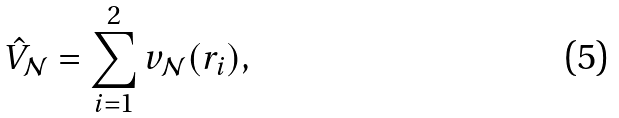<formula> <loc_0><loc_0><loc_500><loc_500>\hat { V } _ { \mathcal { N } } = \sum ^ { 2 } _ { i = 1 } v _ { \mathcal { N } } ( { r } _ { i } ) ,</formula> 